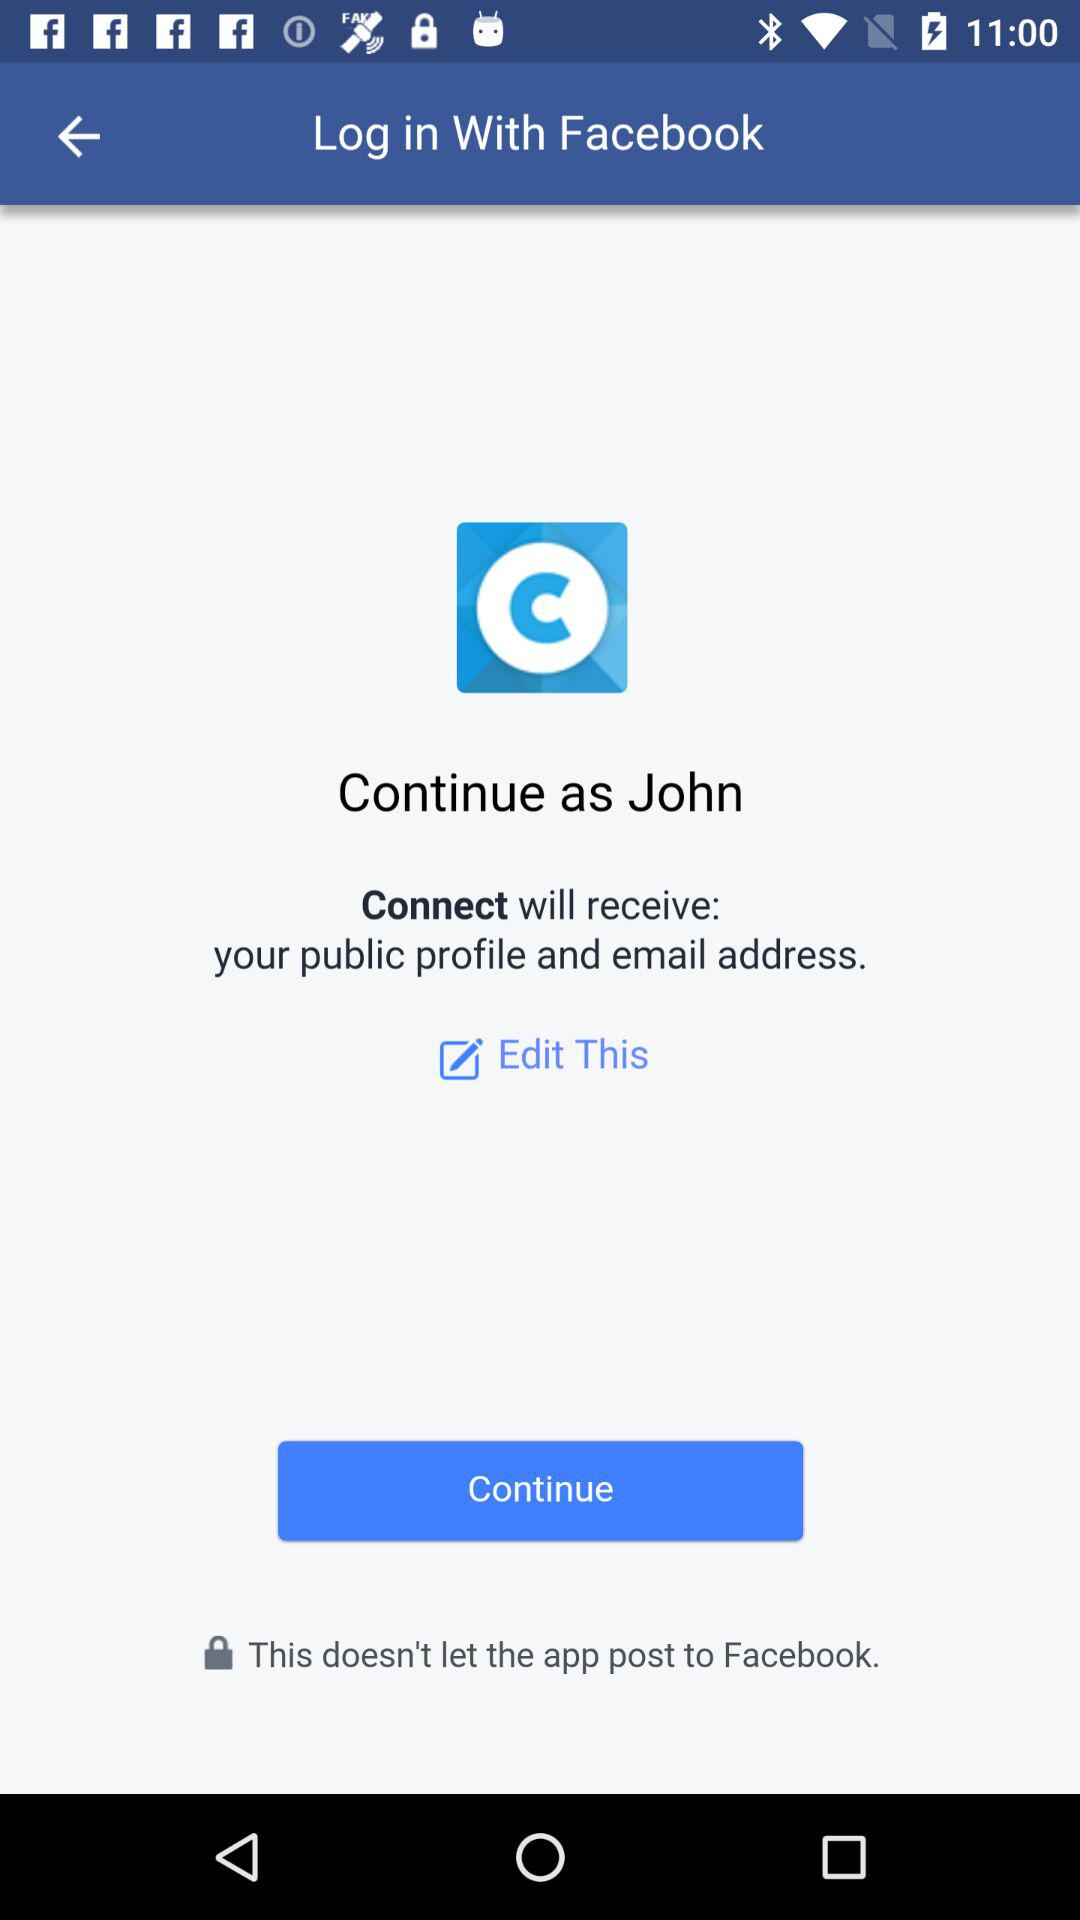What is the user name? The user name is John. 